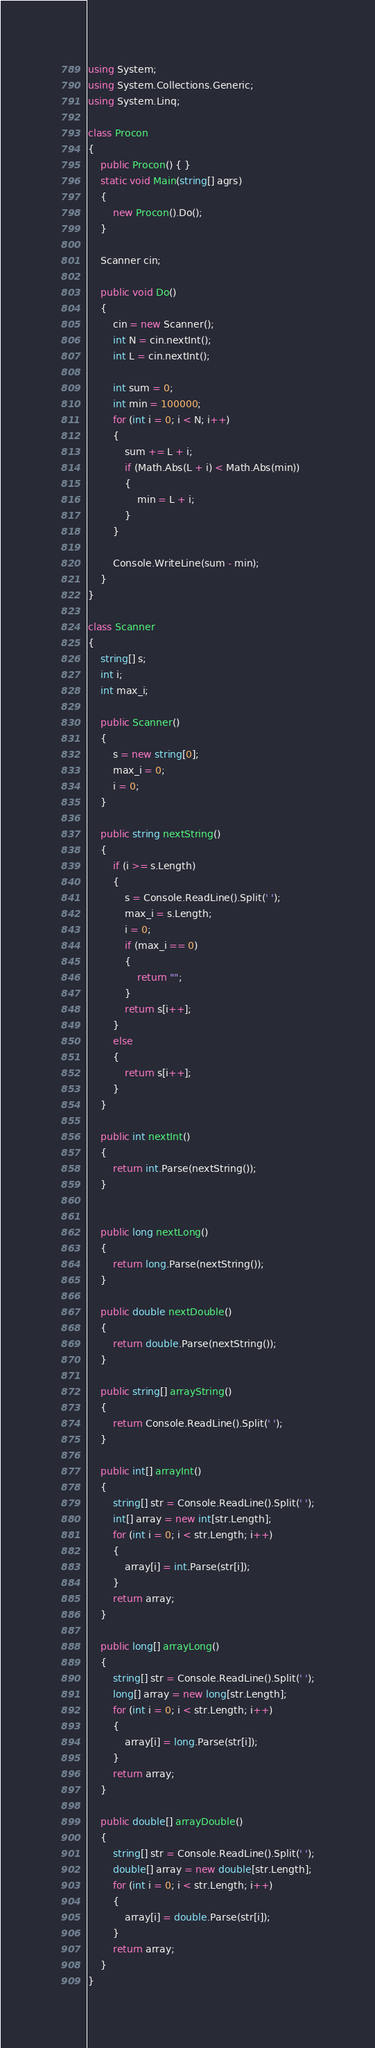Convert code to text. <code><loc_0><loc_0><loc_500><loc_500><_C#_>using System;
using System.Collections.Generic;
using System.Linq;

class Procon
{
    public Procon() { }
    static void Main(string[] agrs)
    {
        new Procon().Do();
    }

    Scanner cin;

    public void Do()
    {
        cin = new Scanner();
        int N = cin.nextInt();
        int L = cin.nextInt();

        int sum = 0;
        int min = 100000;
        for (int i = 0; i < N; i++)
        {
            sum += L + i;
            if (Math.Abs(L + i) < Math.Abs(min))
            {
                min = L + i;
            }
        }

        Console.WriteLine(sum - min);
    }
}

class Scanner
{
    string[] s;
    int i;
    int max_i;

    public Scanner()
    {
        s = new string[0];
        max_i = 0;
        i = 0;
    }

    public string nextString()
    {
        if (i >= s.Length)
        {
            s = Console.ReadLine().Split(' ');
            max_i = s.Length;
            i = 0;
            if (max_i == 0)
            {
                return "";
            }
            return s[i++];
        }
        else
        {
            return s[i++];
        }
    }

    public int nextInt()
    {
        return int.Parse(nextString());
    }


    public long nextLong()
    {
        return long.Parse(nextString());
    }

    public double nextDouble()
    {
        return double.Parse(nextString());
    }

    public string[] arrayString()
    {
        return Console.ReadLine().Split(' ');
    }

    public int[] arrayInt()
    {
        string[] str = Console.ReadLine().Split(' ');
        int[] array = new int[str.Length];
        for (int i = 0; i < str.Length; i++)
        {
            array[i] = int.Parse(str[i]);
        }
        return array;
    }

    public long[] arrayLong()
    {
        string[] str = Console.ReadLine().Split(' ');
        long[] array = new long[str.Length];
        for (int i = 0; i < str.Length; i++)
        {
            array[i] = long.Parse(str[i]);
        }
        return array;
    }

    public double[] arrayDouble()
    {
        string[] str = Console.ReadLine().Split(' ');
        double[] array = new double[str.Length];
        for (int i = 0; i < str.Length; i++)
        {
            array[i] = double.Parse(str[i]);
        }
        return array;
    }
}

</code> 